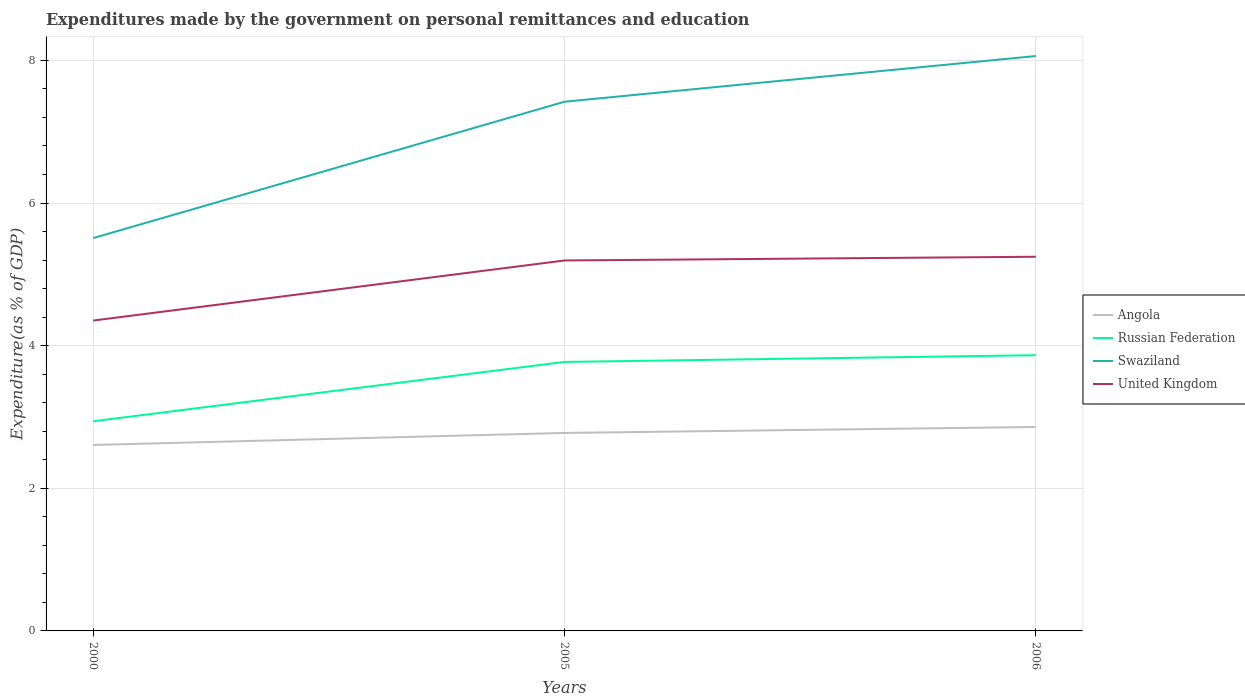Does the line corresponding to Swaziland intersect with the line corresponding to Angola?
Ensure brevity in your answer.  No. Is the number of lines equal to the number of legend labels?
Your response must be concise. Yes. Across all years, what is the maximum expenditures made by the government on personal remittances and education in United Kingdom?
Your response must be concise. 4.35. In which year was the expenditures made by the government on personal remittances and education in Angola maximum?
Ensure brevity in your answer.  2000. What is the total expenditures made by the government on personal remittances and education in Swaziland in the graph?
Provide a short and direct response. -1.91. What is the difference between the highest and the second highest expenditures made by the government on personal remittances and education in United Kingdom?
Your response must be concise. 0.89. What is the difference between the highest and the lowest expenditures made by the government on personal remittances and education in United Kingdom?
Your response must be concise. 2. Is the expenditures made by the government on personal remittances and education in Angola strictly greater than the expenditures made by the government on personal remittances and education in United Kingdom over the years?
Keep it short and to the point. Yes. How many lines are there?
Give a very brief answer. 4. Are the values on the major ticks of Y-axis written in scientific E-notation?
Keep it short and to the point. No. Does the graph contain any zero values?
Provide a short and direct response. No. Does the graph contain grids?
Give a very brief answer. Yes. What is the title of the graph?
Keep it short and to the point. Expenditures made by the government on personal remittances and education. Does "United Kingdom" appear as one of the legend labels in the graph?
Offer a terse response. Yes. What is the label or title of the X-axis?
Your answer should be very brief. Years. What is the label or title of the Y-axis?
Give a very brief answer. Expenditure(as % of GDP). What is the Expenditure(as % of GDP) of Angola in 2000?
Ensure brevity in your answer.  2.61. What is the Expenditure(as % of GDP) in Russian Federation in 2000?
Your answer should be compact. 2.94. What is the Expenditure(as % of GDP) of Swaziland in 2000?
Your answer should be compact. 5.51. What is the Expenditure(as % of GDP) in United Kingdom in 2000?
Your answer should be very brief. 4.35. What is the Expenditure(as % of GDP) in Angola in 2005?
Your response must be concise. 2.78. What is the Expenditure(as % of GDP) in Russian Federation in 2005?
Keep it short and to the point. 3.77. What is the Expenditure(as % of GDP) of Swaziland in 2005?
Your response must be concise. 7.42. What is the Expenditure(as % of GDP) of United Kingdom in 2005?
Ensure brevity in your answer.  5.19. What is the Expenditure(as % of GDP) in Angola in 2006?
Make the answer very short. 2.86. What is the Expenditure(as % of GDP) of Russian Federation in 2006?
Provide a succinct answer. 3.87. What is the Expenditure(as % of GDP) of Swaziland in 2006?
Keep it short and to the point. 8.06. What is the Expenditure(as % of GDP) of United Kingdom in 2006?
Provide a short and direct response. 5.25. Across all years, what is the maximum Expenditure(as % of GDP) of Angola?
Your response must be concise. 2.86. Across all years, what is the maximum Expenditure(as % of GDP) of Russian Federation?
Your response must be concise. 3.87. Across all years, what is the maximum Expenditure(as % of GDP) in Swaziland?
Offer a very short reply. 8.06. Across all years, what is the maximum Expenditure(as % of GDP) in United Kingdom?
Provide a succinct answer. 5.25. Across all years, what is the minimum Expenditure(as % of GDP) in Angola?
Ensure brevity in your answer.  2.61. Across all years, what is the minimum Expenditure(as % of GDP) of Russian Federation?
Your answer should be very brief. 2.94. Across all years, what is the minimum Expenditure(as % of GDP) in Swaziland?
Provide a succinct answer. 5.51. Across all years, what is the minimum Expenditure(as % of GDP) of United Kingdom?
Your answer should be compact. 4.35. What is the total Expenditure(as % of GDP) of Angola in the graph?
Offer a terse response. 8.24. What is the total Expenditure(as % of GDP) in Russian Federation in the graph?
Your response must be concise. 10.58. What is the total Expenditure(as % of GDP) in Swaziland in the graph?
Your answer should be very brief. 20.99. What is the total Expenditure(as % of GDP) in United Kingdom in the graph?
Your answer should be very brief. 14.79. What is the difference between the Expenditure(as % of GDP) in Angola in 2000 and that in 2005?
Provide a succinct answer. -0.17. What is the difference between the Expenditure(as % of GDP) of Russian Federation in 2000 and that in 2005?
Ensure brevity in your answer.  -0.83. What is the difference between the Expenditure(as % of GDP) in Swaziland in 2000 and that in 2005?
Provide a short and direct response. -1.91. What is the difference between the Expenditure(as % of GDP) in United Kingdom in 2000 and that in 2005?
Your response must be concise. -0.84. What is the difference between the Expenditure(as % of GDP) of Angola in 2000 and that in 2006?
Offer a terse response. -0.25. What is the difference between the Expenditure(as % of GDP) of Russian Federation in 2000 and that in 2006?
Offer a terse response. -0.93. What is the difference between the Expenditure(as % of GDP) in Swaziland in 2000 and that in 2006?
Offer a terse response. -2.55. What is the difference between the Expenditure(as % of GDP) of United Kingdom in 2000 and that in 2006?
Keep it short and to the point. -0.89. What is the difference between the Expenditure(as % of GDP) of Angola in 2005 and that in 2006?
Give a very brief answer. -0.08. What is the difference between the Expenditure(as % of GDP) in Russian Federation in 2005 and that in 2006?
Give a very brief answer. -0.09. What is the difference between the Expenditure(as % of GDP) of Swaziland in 2005 and that in 2006?
Ensure brevity in your answer.  -0.64. What is the difference between the Expenditure(as % of GDP) in United Kingdom in 2005 and that in 2006?
Make the answer very short. -0.05. What is the difference between the Expenditure(as % of GDP) of Angola in 2000 and the Expenditure(as % of GDP) of Russian Federation in 2005?
Your answer should be very brief. -1.16. What is the difference between the Expenditure(as % of GDP) of Angola in 2000 and the Expenditure(as % of GDP) of Swaziland in 2005?
Your answer should be compact. -4.81. What is the difference between the Expenditure(as % of GDP) in Angola in 2000 and the Expenditure(as % of GDP) in United Kingdom in 2005?
Provide a short and direct response. -2.59. What is the difference between the Expenditure(as % of GDP) in Russian Federation in 2000 and the Expenditure(as % of GDP) in Swaziland in 2005?
Provide a succinct answer. -4.48. What is the difference between the Expenditure(as % of GDP) in Russian Federation in 2000 and the Expenditure(as % of GDP) in United Kingdom in 2005?
Your response must be concise. -2.25. What is the difference between the Expenditure(as % of GDP) of Swaziland in 2000 and the Expenditure(as % of GDP) of United Kingdom in 2005?
Provide a short and direct response. 0.31. What is the difference between the Expenditure(as % of GDP) in Angola in 2000 and the Expenditure(as % of GDP) in Russian Federation in 2006?
Offer a very short reply. -1.26. What is the difference between the Expenditure(as % of GDP) in Angola in 2000 and the Expenditure(as % of GDP) in Swaziland in 2006?
Your answer should be very brief. -5.45. What is the difference between the Expenditure(as % of GDP) in Angola in 2000 and the Expenditure(as % of GDP) in United Kingdom in 2006?
Your response must be concise. -2.64. What is the difference between the Expenditure(as % of GDP) in Russian Federation in 2000 and the Expenditure(as % of GDP) in Swaziland in 2006?
Offer a terse response. -5.12. What is the difference between the Expenditure(as % of GDP) in Russian Federation in 2000 and the Expenditure(as % of GDP) in United Kingdom in 2006?
Offer a very short reply. -2.31. What is the difference between the Expenditure(as % of GDP) in Swaziland in 2000 and the Expenditure(as % of GDP) in United Kingdom in 2006?
Keep it short and to the point. 0.26. What is the difference between the Expenditure(as % of GDP) in Angola in 2005 and the Expenditure(as % of GDP) in Russian Federation in 2006?
Your response must be concise. -1.09. What is the difference between the Expenditure(as % of GDP) of Angola in 2005 and the Expenditure(as % of GDP) of Swaziland in 2006?
Offer a terse response. -5.29. What is the difference between the Expenditure(as % of GDP) in Angola in 2005 and the Expenditure(as % of GDP) in United Kingdom in 2006?
Offer a terse response. -2.47. What is the difference between the Expenditure(as % of GDP) of Russian Federation in 2005 and the Expenditure(as % of GDP) of Swaziland in 2006?
Ensure brevity in your answer.  -4.29. What is the difference between the Expenditure(as % of GDP) in Russian Federation in 2005 and the Expenditure(as % of GDP) in United Kingdom in 2006?
Make the answer very short. -1.48. What is the difference between the Expenditure(as % of GDP) of Swaziland in 2005 and the Expenditure(as % of GDP) of United Kingdom in 2006?
Ensure brevity in your answer.  2.17. What is the average Expenditure(as % of GDP) in Angola per year?
Keep it short and to the point. 2.75. What is the average Expenditure(as % of GDP) of Russian Federation per year?
Offer a terse response. 3.53. What is the average Expenditure(as % of GDP) of Swaziland per year?
Your answer should be compact. 7. What is the average Expenditure(as % of GDP) of United Kingdom per year?
Offer a very short reply. 4.93. In the year 2000, what is the difference between the Expenditure(as % of GDP) of Angola and Expenditure(as % of GDP) of Russian Federation?
Give a very brief answer. -0.33. In the year 2000, what is the difference between the Expenditure(as % of GDP) in Angola and Expenditure(as % of GDP) in Swaziland?
Your answer should be compact. -2.9. In the year 2000, what is the difference between the Expenditure(as % of GDP) of Angola and Expenditure(as % of GDP) of United Kingdom?
Your answer should be compact. -1.74. In the year 2000, what is the difference between the Expenditure(as % of GDP) of Russian Federation and Expenditure(as % of GDP) of Swaziland?
Offer a very short reply. -2.57. In the year 2000, what is the difference between the Expenditure(as % of GDP) of Russian Federation and Expenditure(as % of GDP) of United Kingdom?
Your response must be concise. -1.41. In the year 2000, what is the difference between the Expenditure(as % of GDP) of Swaziland and Expenditure(as % of GDP) of United Kingdom?
Provide a succinct answer. 1.16. In the year 2005, what is the difference between the Expenditure(as % of GDP) of Angola and Expenditure(as % of GDP) of Russian Federation?
Ensure brevity in your answer.  -1. In the year 2005, what is the difference between the Expenditure(as % of GDP) of Angola and Expenditure(as % of GDP) of Swaziland?
Your answer should be very brief. -4.64. In the year 2005, what is the difference between the Expenditure(as % of GDP) of Angola and Expenditure(as % of GDP) of United Kingdom?
Your response must be concise. -2.42. In the year 2005, what is the difference between the Expenditure(as % of GDP) in Russian Federation and Expenditure(as % of GDP) in Swaziland?
Your answer should be compact. -3.65. In the year 2005, what is the difference between the Expenditure(as % of GDP) of Russian Federation and Expenditure(as % of GDP) of United Kingdom?
Provide a succinct answer. -1.42. In the year 2005, what is the difference between the Expenditure(as % of GDP) of Swaziland and Expenditure(as % of GDP) of United Kingdom?
Offer a very short reply. 2.23. In the year 2006, what is the difference between the Expenditure(as % of GDP) of Angola and Expenditure(as % of GDP) of Russian Federation?
Provide a succinct answer. -1.01. In the year 2006, what is the difference between the Expenditure(as % of GDP) in Angola and Expenditure(as % of GDP) in Swaziland?
Keep it short and to the point. -5.2. In the year 2006, what is the difference between the Expenditure(as % of GDP) of Angola and Expenditure(as % of GDP) of United Kingdom?
Offer a terse response. -2.39. In the year 2006, what is the difference between the Expenditure(as % of GDP) in Russian Federation and Expenditure(as % of GDP) in Swaziland?
Your answer should be compact. -4.2. In the year 2006, what is the difference between the Expenditure(as % of GDP) in Russian Federation and Expenditure(as % of GDP) in United Kingdom?
Keep it short and to the point. -1.38. In the year 2006, what is the difference between the Expenditure(as % of GDP) in Swaziland and Expenditure(as % of GDP) in United Kingdom?
Offer a very short reply. 2.81. What is the ratio of the Expenditure(as % of GDP) of Angola in 2000 to that in 2005?
Make the answer very short. 0.94. What is the ratio of the Expenditure(as % of GDP) in Russian Federation in 2000 to that in 2005?
Provide a short and direct response. 0.78. What is the ratio of the Expenditure(as % of GDP) in Swaziland in 2000 to that in 2005?
Make the answer very short. 0.74. What is the ratio of the Expenditure(as % of GDP) of United Kingdom in 2000 to that in 2005?
Ensure brevity in your answer.  0.84. What is the ratio of the Expenditure(as % of GDP) of Angola in 2000 to that in 2006?
Provide a succinct answer. 0.91. What is the ratio of the Expenditure(as % of GDP) of Russian Federation in 2000 to that in 2006?
Ensure brevity in your answer.  0.76. What is the ratio of the Expenditure(as % of GDP) in Swaziland in 2000 to that in 2006?
Keep it short and to the point. 0.68. What is the ratio of the Expenditure(as % of GDP) of United Kingdom in 2000 to that in 2006?
Ensure brevity in your answer.  0.83. What is the ratio of the Expenditure(as % of GDP) in Angola in 2005 to that in 2006?
Your answer should be compact. 0.97. What is the ratio of the Expenditure(as % of GDP) in Russian Federation in 2005 to that in 2006?
Offer a terse response. 0.98. What is the ratio of the Expenditure(as % of GDP) of Swaziland in 2005 to that in 2006?
Give a very brief answer. 0.92. What is the ratio of the Expenditure(as % of GDP) of United Kingdom in 2005 to that in 2006?
Keep it short and to the point. 0.99. What is the difference between the highest and the second highest Expenditure(as % of GDP) in Angola?
Your response must be concise. 0.08. What is the difference between the highest and the second highest Expenditure(as % of GDP) of Russian Federation?
Give a very brief answer. 0.09. What is the difference between the highest and the second highest Expenditure(as % of GDP) of Swaziland?
Your answer should be very brief. 0.64. What is the difference between the highest and the second highest Expenditure(as % of GDP) in United Kingdom?
Make the answer very short. 0.05. What is the difference between the highest and the lowest Expenditure(as % of GDP) of Angola?
Offer a terse response. 0.25. What is the difference between the highest and the lowest Expenditure(as % of GDP) in Russian Federation?
Keep it short and to the point. 0.93. What is the difference between the highest and the lowest Expenditure(as % of GDP) of Swaziland?
Provide a succinct answer. 2.55. What is the difference between the highest and the lowest Expenditure(as % of GDP) of United Kingdom?
Your answer should be compact. 0.89. 